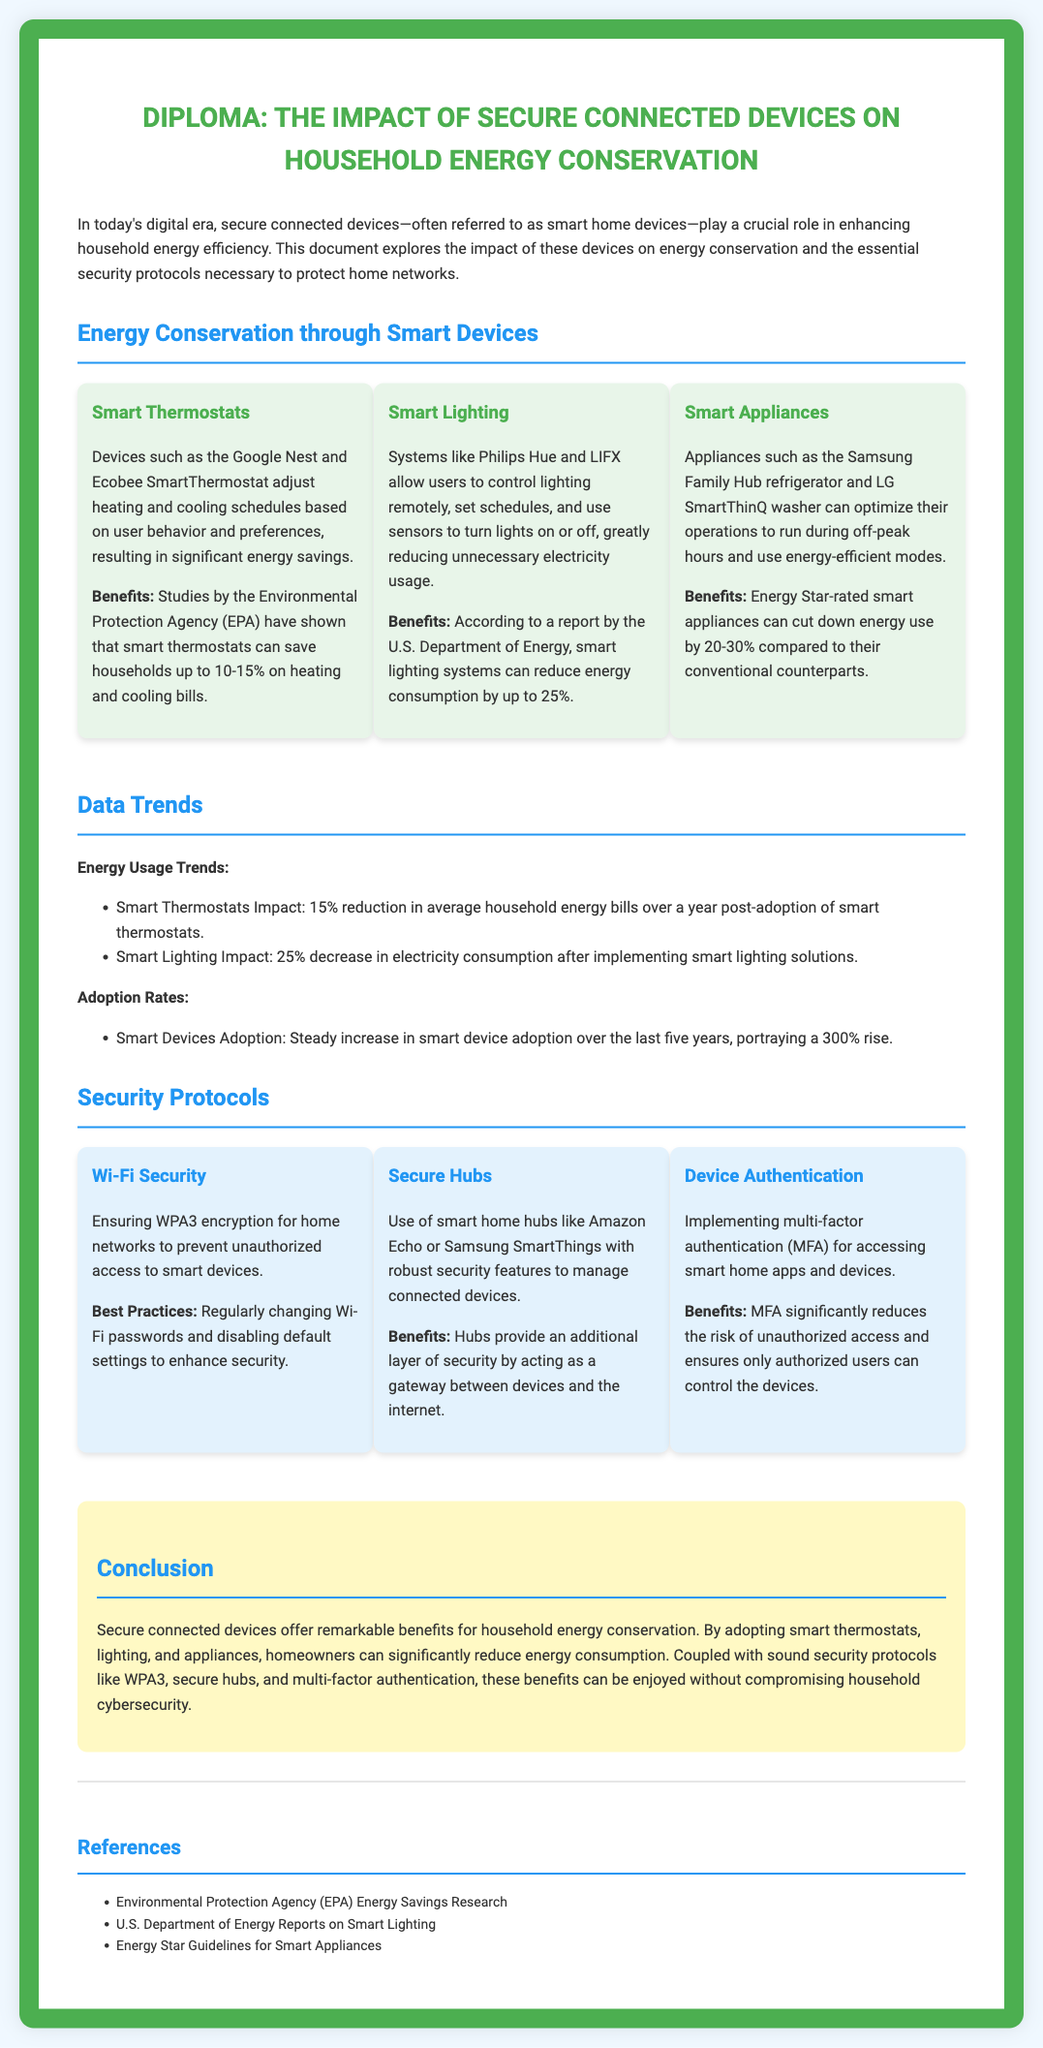what is the title of the document? The title of the document is presented prominently at the top of the rendered output, stating its focus on energy conservation and connected devices.
Answer: The Impact of Secure Connected Devices on Household Energy Conservation how much can smart thermostats save on heating and cooling bills? The document specifies the savings figure mentioned by the EPA for smart thermostats, which is a range based on research.
Answer: 10-15% which smart lighting system is mentioned as a leading solution? The document lists specific brands in the category of smart lighting systems, highlighting a popular option for energy efficiency.
Answer: Philips Hue what reduction in electricity consumption is linked to smart lighting? The document provides specific percentage estimates based on reports related to the impact of smart lighting solutions.
Answer: 25% what is the percentage increase in smart device adoption over the last five years? The document mentions a significant growth statistic concerning the adoption rates of smart devices in recent years.
Answer: 300% what security feature is recommended for home networks? The document emphasizes the importance of a specific encryption standard that enhances security for Wi-Fi networks in homes.
Answer: WPA3 what layer of security do smart home hubs provide? The document describes the function of smart home hubs in managing connected devices and improving household security.
Answer: Additional layer which protocol significantly reduces unauthorized access risk? The document highlights a specific security measure that enhances protection against unauthorized access in smart home setups.
Answer: Multi-factor authentication what is the primary purpose of the diploma? The document outlines the overall objective that combines effective energy conservation practices with security considerations for households.
Answer: To explore the impact of secure connected devices on energy conservation 